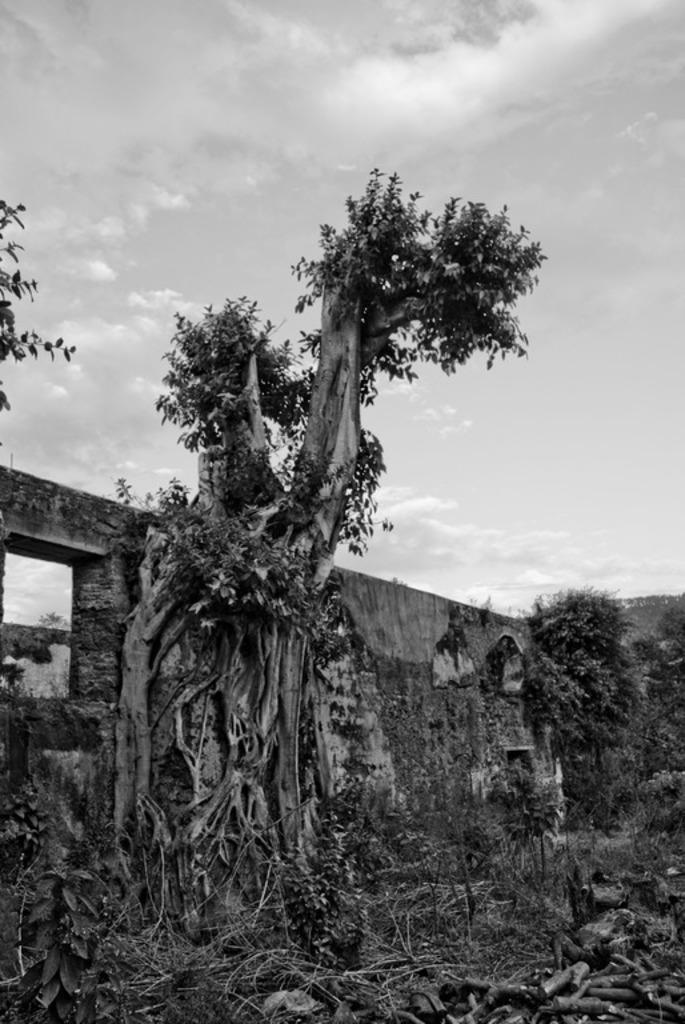Can you describe this image briefly? In this image we can see trees, plants, grass, there are trunks, also we can see the wall and the sky, the picture is taken in black and white mode. 